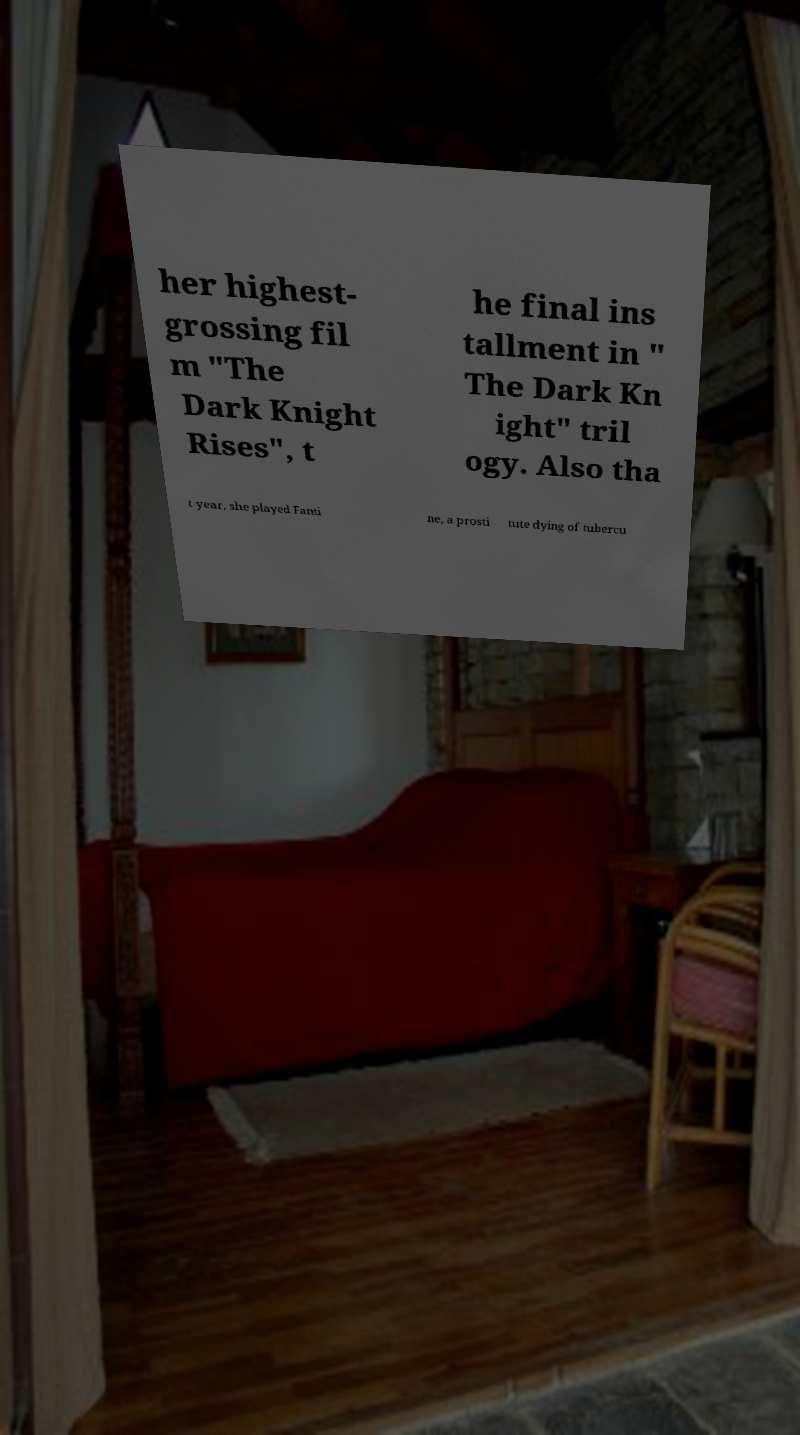Can you accurately transcribe the text from the provided image for me? her highest- grossing fil m "The Dark Knight Rises", t he final ins tallment in " The Dark Kn ight" tril ogy. Also tha t year, she played Fanti ne, a prosti tute dying of tubercu 